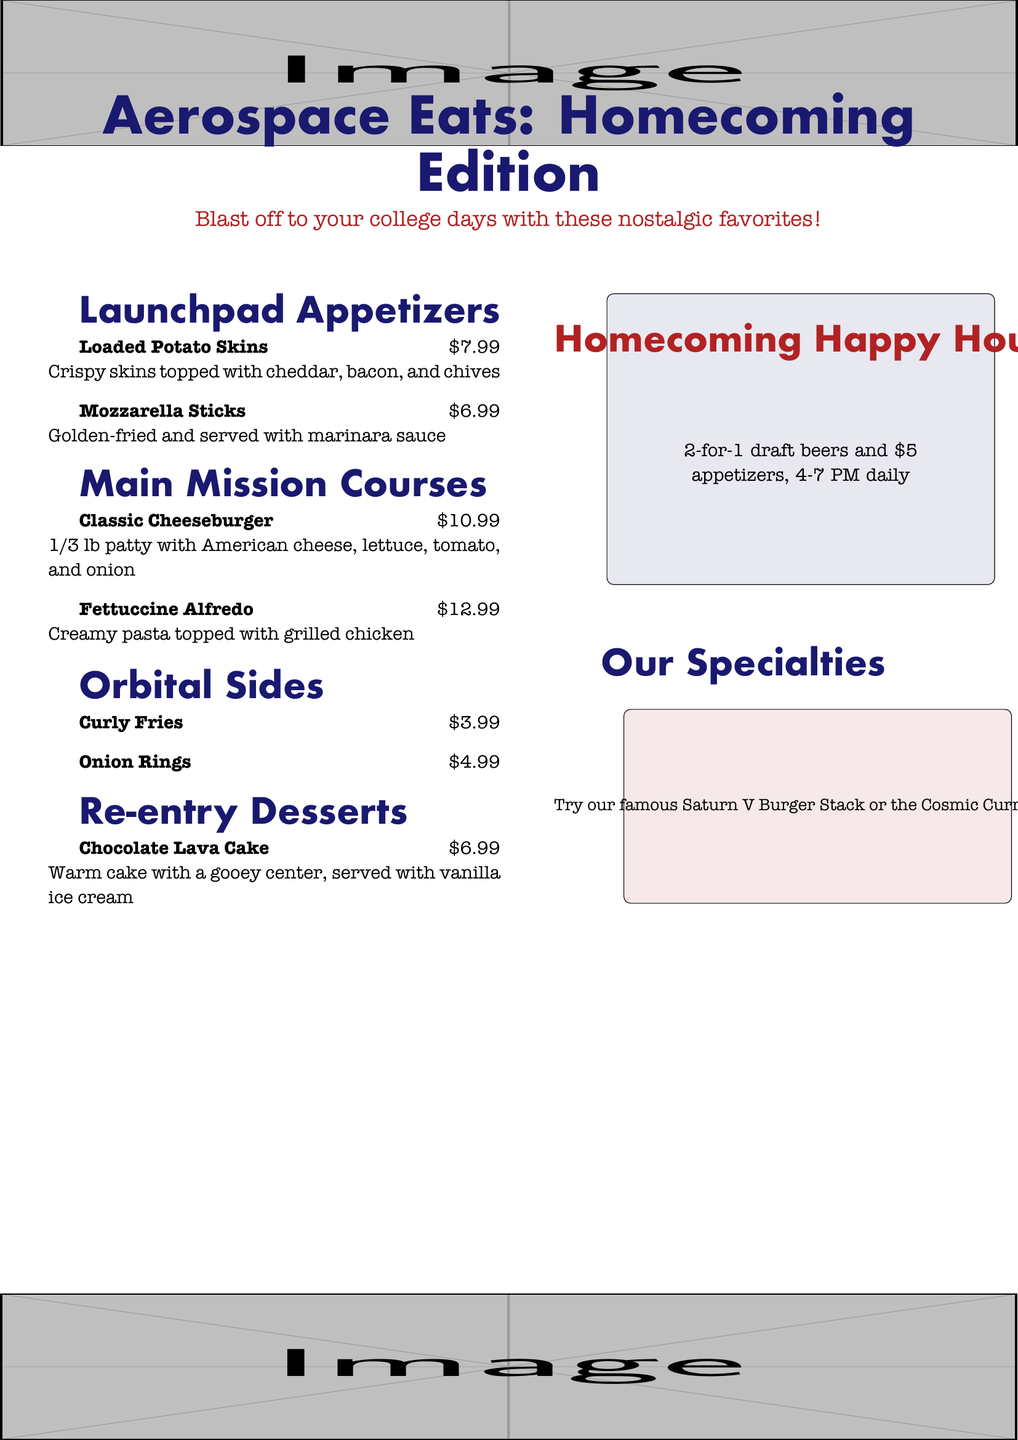What is the title of the menu? The title of the menu is prominently displayed at the top of the document, which is "Aerospace Eats: Homecoming Edition."
Answer: Aerospace Eats: Homecoming Edition How much do Loaded Potato Skins cost? The price for Loaded Potato Skins is listed next to the description in the appetizers section, which is $7.99.
Answer: $7.99 What is included in the Classic Cheeseburger? The Classic Cheeseburger's ingredients are mentioned in the main courses section, which includes 1/3 lb patty, American cheese, lettuce, tomato, and onion.
Answer: 1/3 lb patty with American cheese, lettuce, tomato, and onion What time is the Homecoming Happy Hour? The Homecoming Happy Hour hours are specified in the happy hour section of the menu as being from 4-7 PM daily.
Answer: 4-7 PM How many appetizers can be ordered during Happy Hour for $5? The Happy Hour section states that customers can get $5 appetizers, implying multiple choices but does not specify a number. Therefore, the answer is reasonably deduced from the context.
Answer: Multiple How much do Curly Fries cost? The cost of Curly Fries is presented next to its name in the sides section, which is $3.99.
Answer: $3.99 What dessert has a gooey center? The dessert description mentions that Chocolate Lava Cake has a gooey center, making it identifiable as the answer.
Answer: Chocolate Lava Cake What color is used for the main title? The color specified for the main title in the menu is "spaceblue."
Answer: spaceblue 